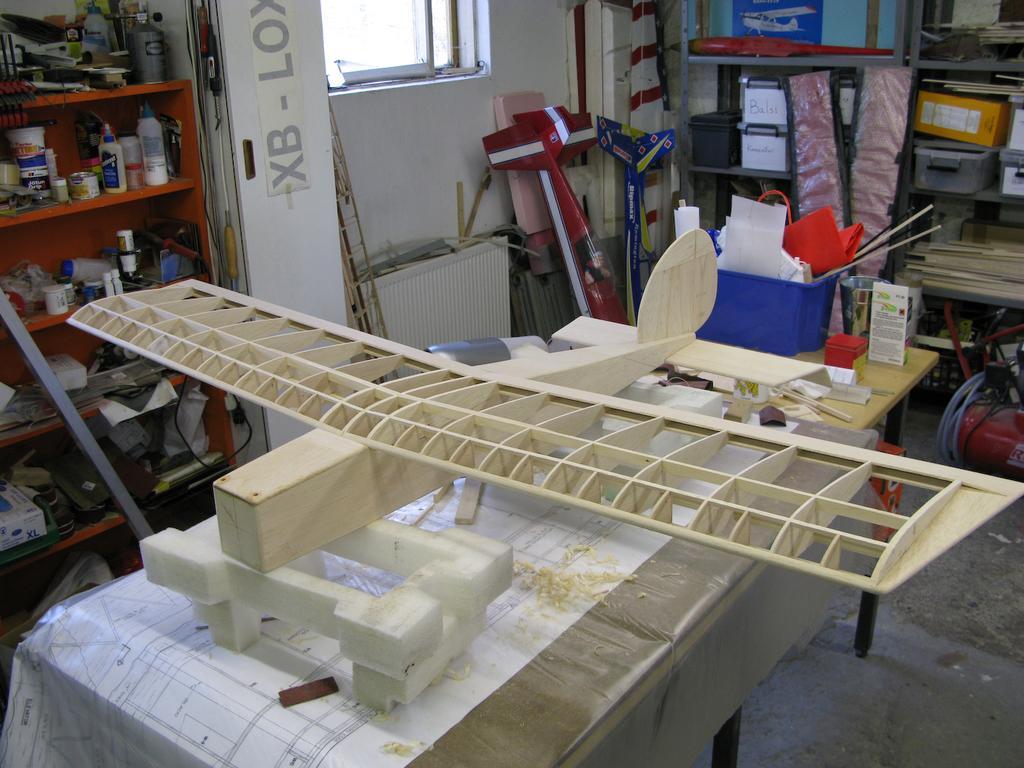Describe this image in one or two sentences. In this image we can see a craft made with wood which is placed on the table. We can also see some sticks, objects and papers in a container and some boxes beside it. On the left side we can see a metal rod and a paper on a wall. We can also see some bottles, containers, wire and some objects placed in the shelves. We can also see a window, a ladder, some objects, boards and a device on the floor. We can also see some books, boxes and containers placed in the racks. 